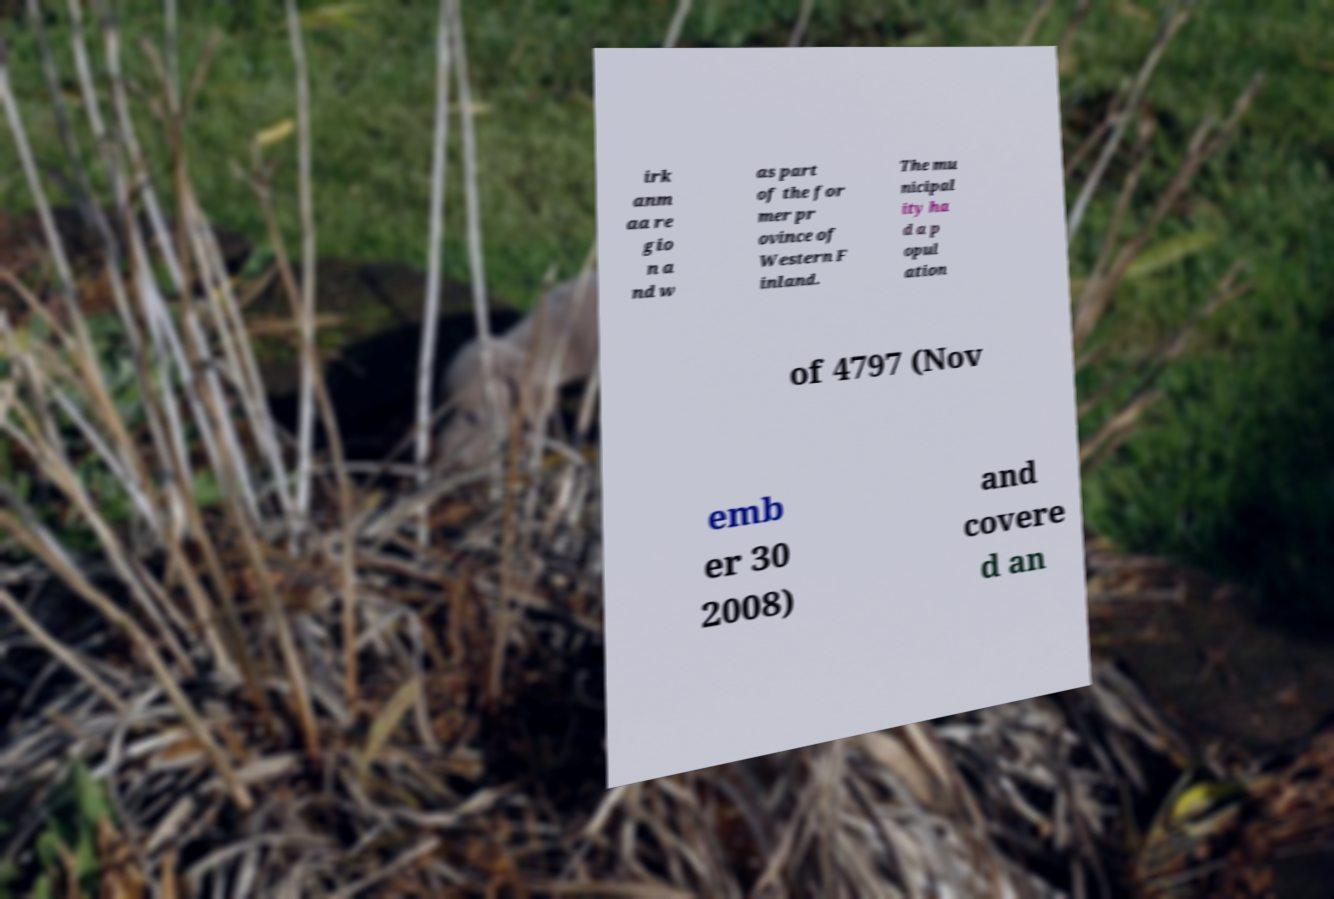What messages or text are displayed in this image? I need them in a readable, typed format. irk anm aa re gio n a nd w as part of the for mer pr ovince of Western F inland. The mu nicipal ity ha d a p opul ation of 4797 (Nov emb er 30 2008) and covere d an 